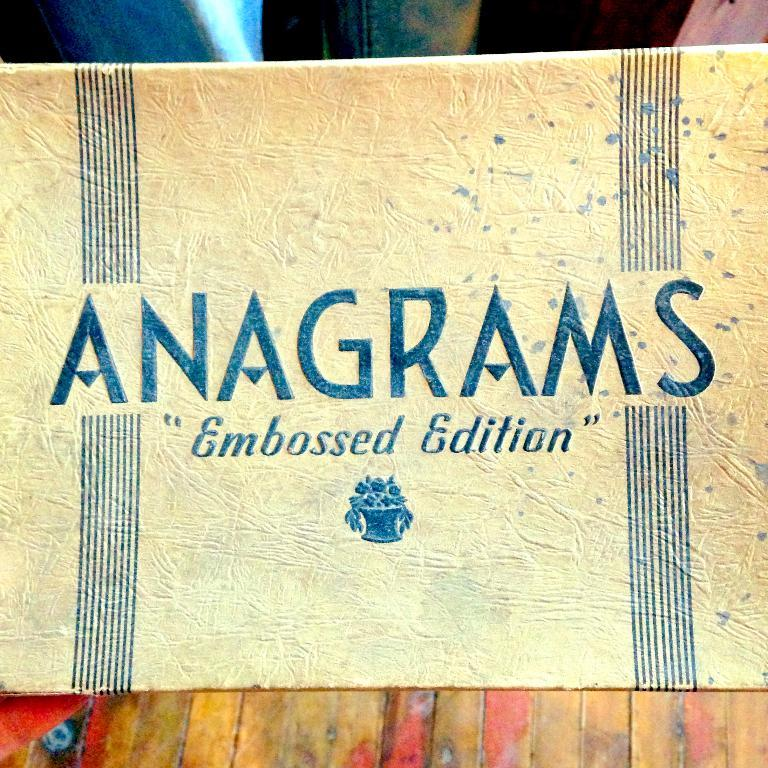Provide a one-sentence caption for the provided image. a close up of an Anagrams card Embossed Edition. 